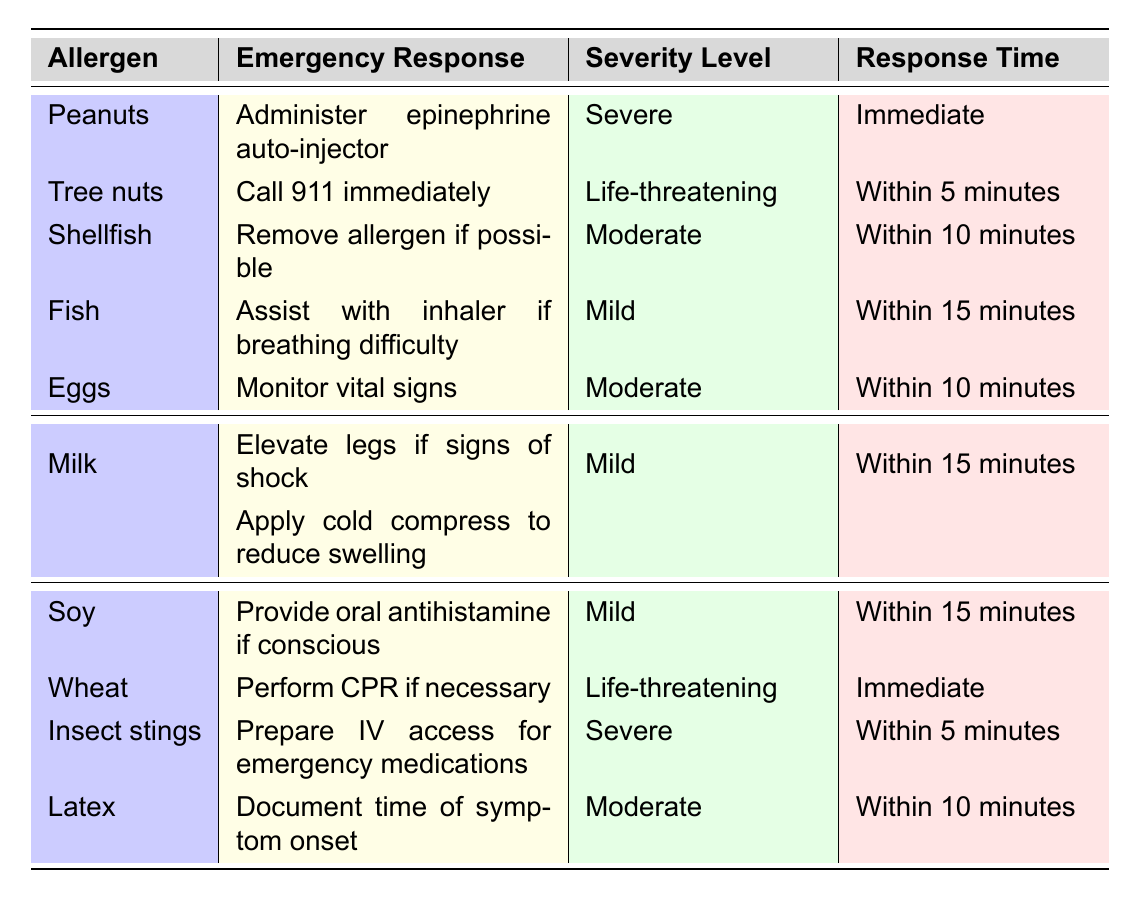What is the emergency response for a peanut allergy? According to the table, the response for a peanut allergy is to administer an epinephrine auto-injector.
Answer: Administer epinephrine auto-injector Which allergen requires the response "Call 911 immediately"? The table indicates that the allergen requiring this response is tree nuts.
Answer: Tree nuts What is the severity level of an egg allergy? The table shows that the severity level for an egg allergy is moderate.
Answer: Moderate How many allergens have a life-threatening severity level? By reviewing the table, we see that two allergens (tree nuts and wheat) are classified as life-threatening.
Answer: 2 Which allergen has the longest response time to treatment? The allergen with the longest response time in the table is fish, which has a response time within 15 minutes.
Answer: Fish Is it true that insect stings require a response within 10 minutes? The table shows that insect stings require a response time within 5 minutes, making this statement false.
Answer: False What measures should be prepared if someone has a milk allergy? The table states to elevate the legs if signs of shock and apply a cold compress to reduce swelling as responses for a milk allergy.
Answer: Elevate legs, apply cold compress Among the allergens listed, which one has both mild severity and a response time of within 15 minutes? The table shows that soy allergy has a mild severity level and a response time within 15 minutes.
Answer: Soy What is the response time for a shellfish allergy? According to the table, the response time for shellfish allergy is within 10 minutes.
Answer: Within 10 minutes If a person shows signs of anaphylaxis due to a fish allergy, what should be the immediate response? The table indicates that if anaphylaxis occurs due to a fish allergy, the appropriate response is to assist with an inhaler if there is breathing difficulty.
Answer: Assist with inhaler 